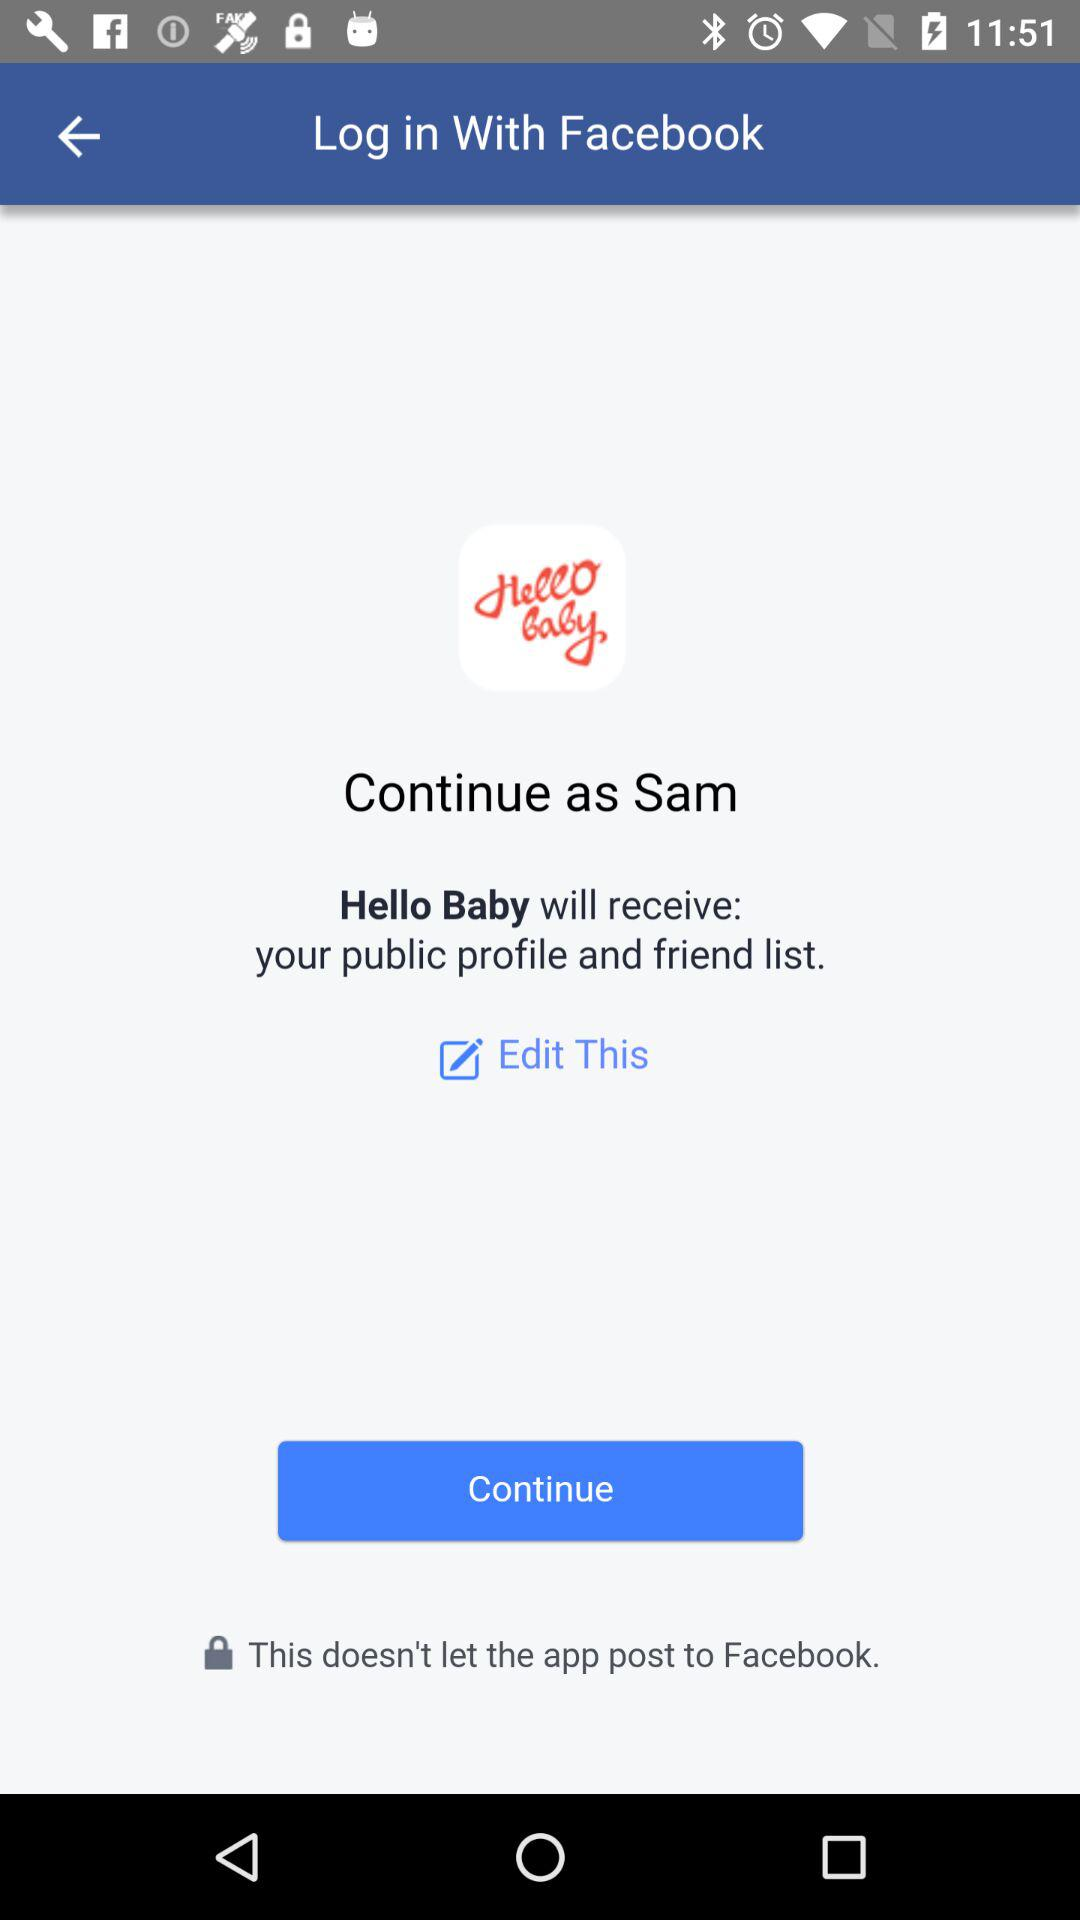What is the name of the user? The name of the user is Sam. 